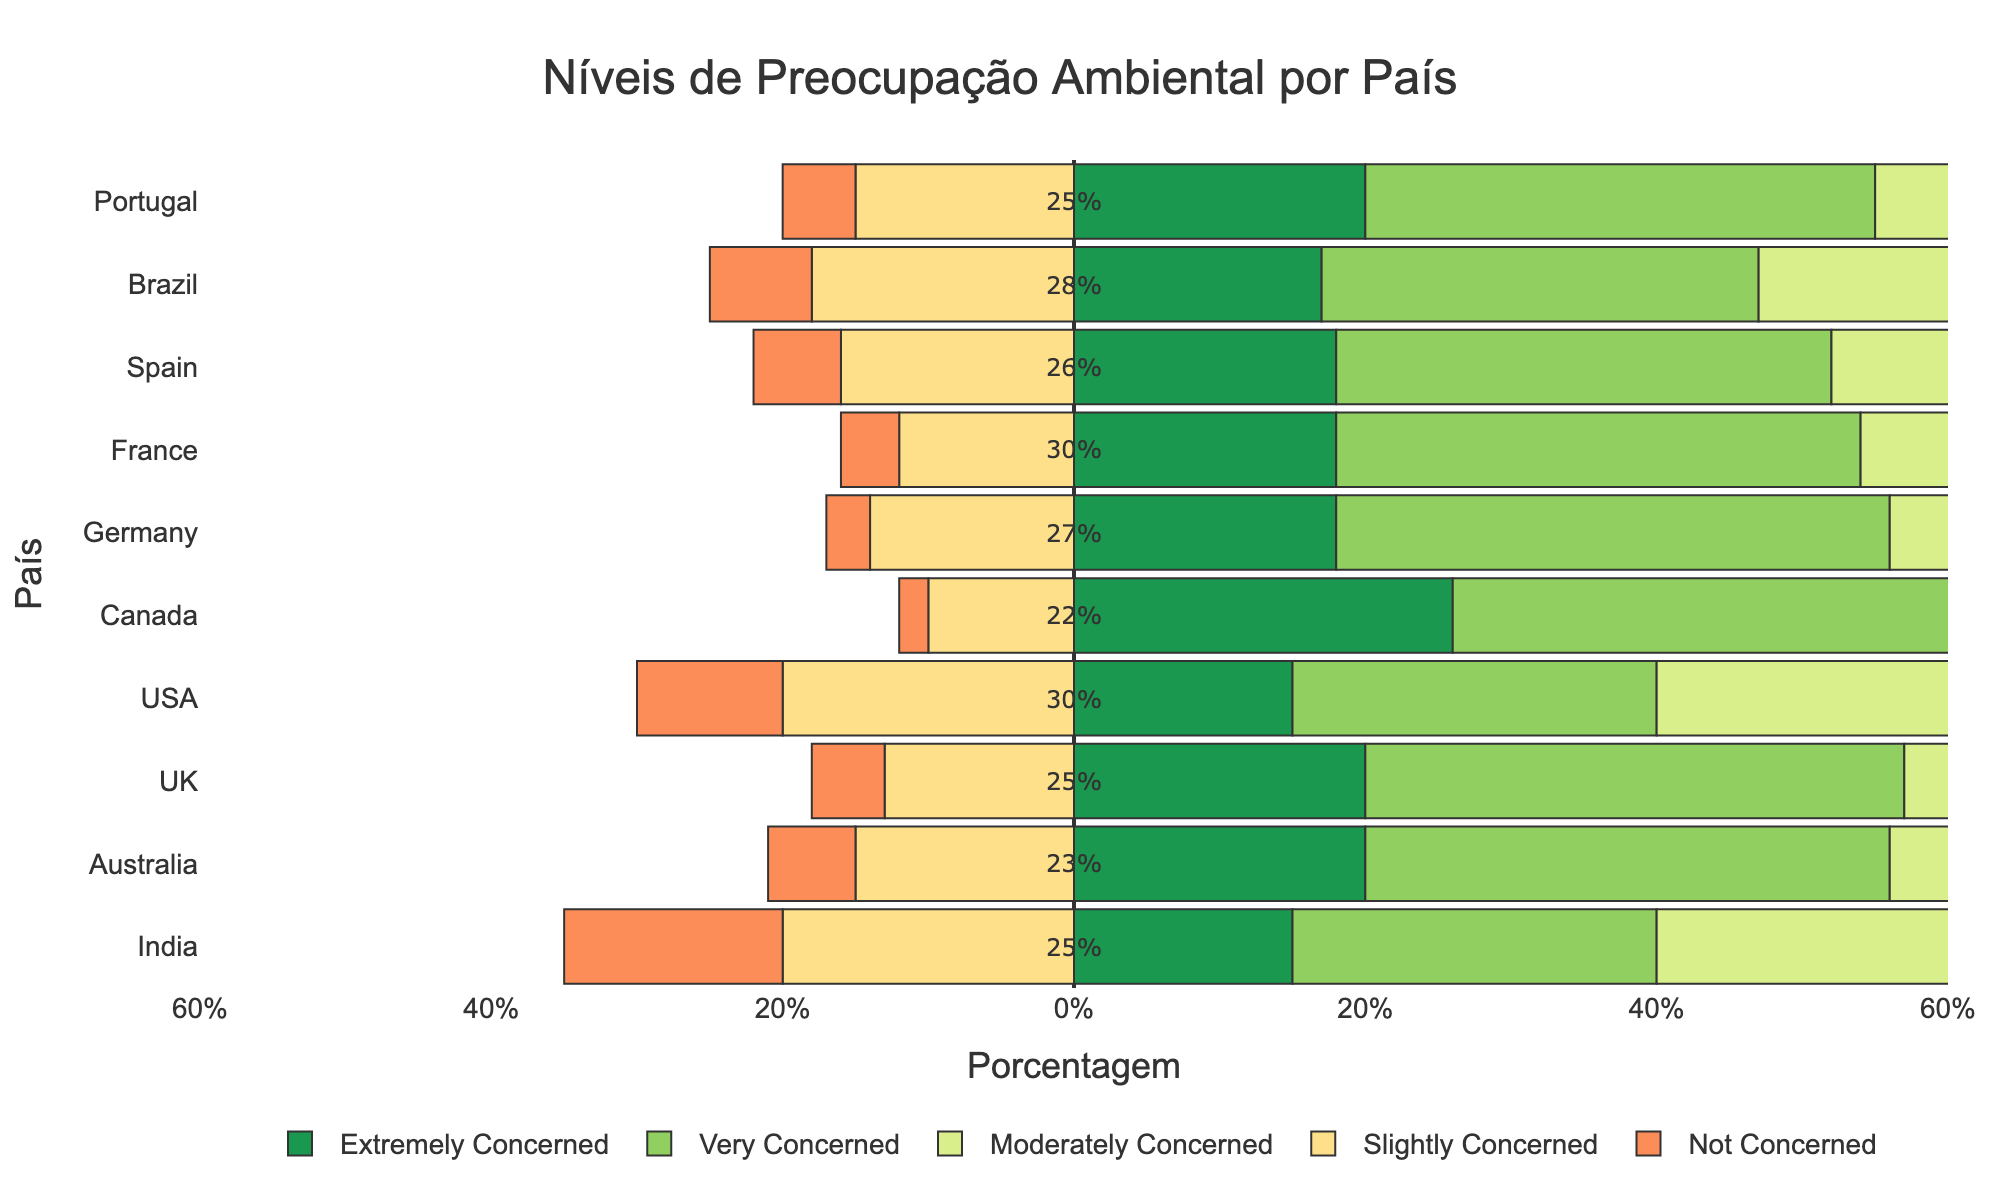Which country has the highest percentage of people who are extremely concerned with environmental issues? Look at the bar representing "extremely concerned" for each country. Canada has the longest green bar for "extremely concerned."
Answer: Canada Which two countries have the lowest percentage of people who are not concerned with environmental issues? Check the bars representing "not concerned" for each country. Canada and Germany have the shortest red bars for "not concerned."
Answer: Canada and Germany What is the total percentage of people in Brazil who are at least moderately concerned with environmental issues? Summing up the percentages for "moderately concerned," "very concerned," and "extremely concerned" in Brazil: 28 + 30 + 17 = 75%.
Answer: 75% Compare the levels of slight concern between Portugal and Australia. Which country has more people slightly concerned? Look at the bars representing "slightly concerned" for Portugal and Australia. Portugal has 15%, and Australia has 15%. Both percentages are equal.
Answer: Both equal at 15% Which country has the highest percentage of people very concerned with environmental issues? Look at the bar representing "very concerned" for each country. Canada has the longest light green bar for "very concerned" with 40%.
Answer: Canada Which country has the lowest level of concern across all categories? India has the highest percentages in the "not concerned" and "slightly concerned" categories; combined with other data points, it shows overall lower concern.
Answer: India In which country is the discrepancy between those extremely concerned and those moderately concerned the greatest? Calculate the difference between the percentages of "extremely concerned" and "moderately concerned" for each country. The largest difference is for Canada: 26% (extremely) - 22% (moderately) = 4%.
Answer: Canada What's the midpoint value (moderately concerned) for the majority of countries? The annotation on the midpoint value for most countries on the y-axis shows it around 25-30% for many countries.
Answer: 25%-30% Which country's bar for "not concerned" is closest in length to its bar for "very concerned"? Compare the lengths of the bars for "not concerned" and "very concerned" across all countries. The USA has 10% for "not concerned" and 25% for "very concerned" but Brazil is the closest with 7% "not concerned" and 30% "very concerned."
Answer: Brazil 